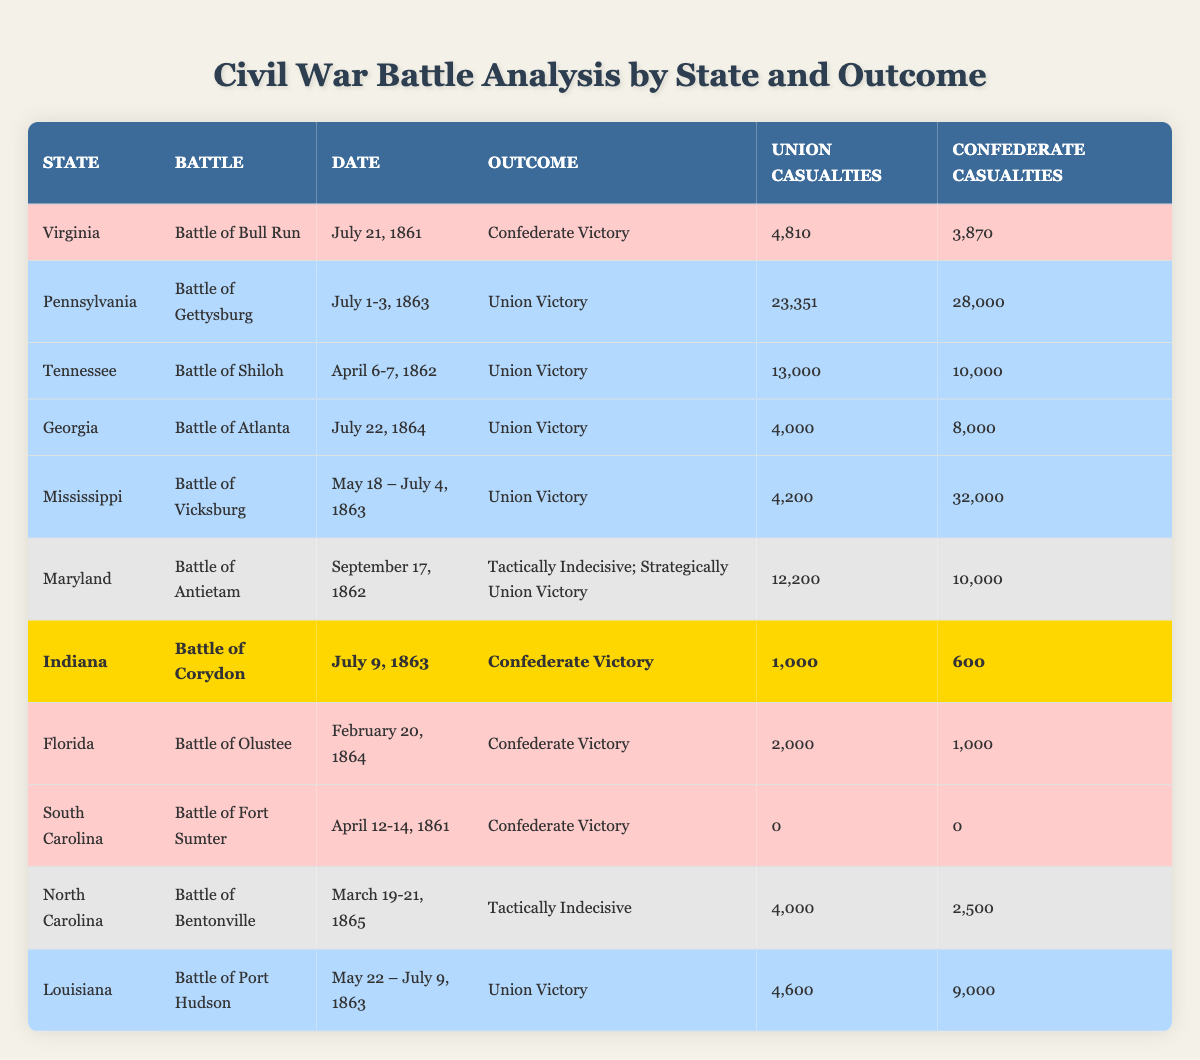What was the outcome of the Battle of Gettysburg? The table lists the outcome for the Battle of Gettysburg under the "Outcome" column. It states "Union Victory".
Answer: Union Victory How many Union casualties occurred in the Battle of Antietam? By looking at the row for the Battle of Antietam, the Union casualties are found in the "Union Casualties" column, which shows 12,200.
Answer: 12,200 Which battle had the highest number of Confederate casualties? The table shows the Confederate casualties for each battle. By comparing these numbers, the Battle of Vicksburg has the highest at 32,000.
Answer: Battle of Vicksburg In which state did the Battle of Corydon take place? The "State" column in the table indicates that the Battle of Corydon occurred in Indiana.
Answer: Indiana What is the difference in Union casualties between the Battle of Shiloh and the Battle of Atlanta? The Union casualties for Shiloh are 13,000 and for Atlanta are 4,000. The difference is 13,000 - 4,000 = 9,000.
Answer: 9,000 How many battles had a Confederate victory? By counting the rows marked with "Confederate Victory" under the "Outcome" column, there are 5 battles that resulted in a Confederate victory.
Answer: 5 Which battle had the lowest number of casualties overall? The table shows that the Battle of Fort Sumter had 0 casualties for both sides, which is the lowest when compared to others.
Answer: Battle of Fort Sumter What was the total number of Union casualties from the battles listed in Mississippi? In the row for Mississippi (Battle of Vicksburg), the Union casualties are 4,200. This is the only battle recorded for Mississippi, so the total is just 4,200.
Answer: 4,200 Is the outcome of the Battle of Bentonville classified as a victory? The outcome listed for the Battle of Bentonville is "Tactically Indecisive", which does not qualify as a victory for either side.
Answer: No Which state experienced both Union and Confederate victories? The table shows that Virginia has one battle with a Confederate victory (Battle of Bull Run), while several battles in other states have Union victories. However, no state has both outcomes in the table data.
Answer: None 